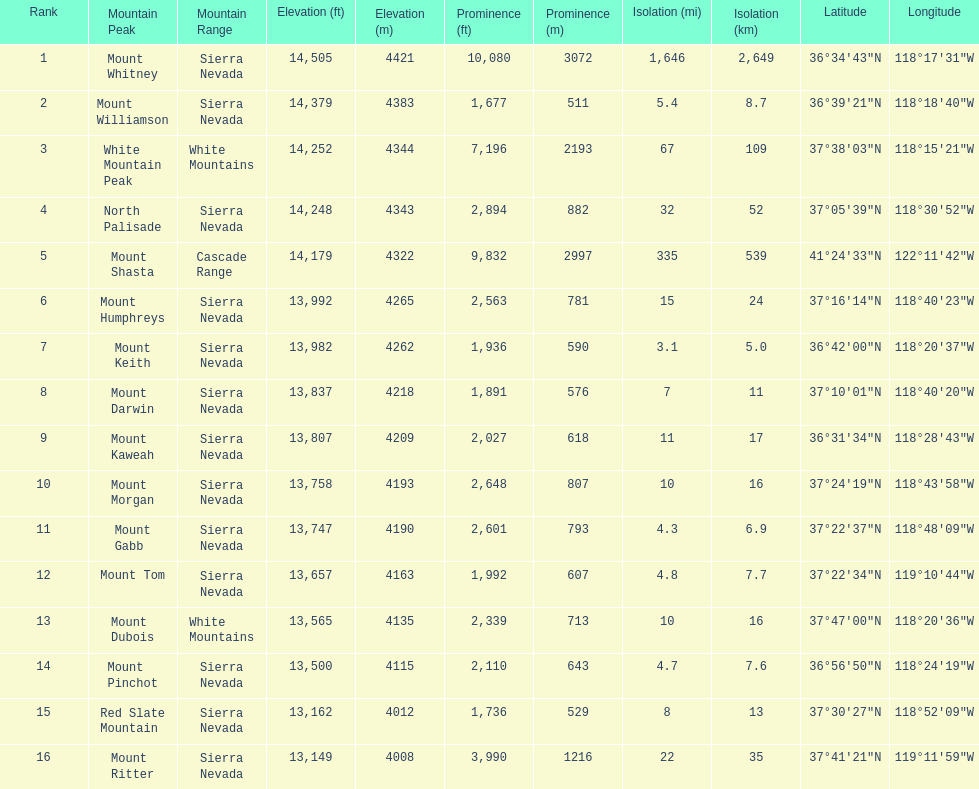What is the total elevation (in ft) of mount whitney? 14,505 ft. 